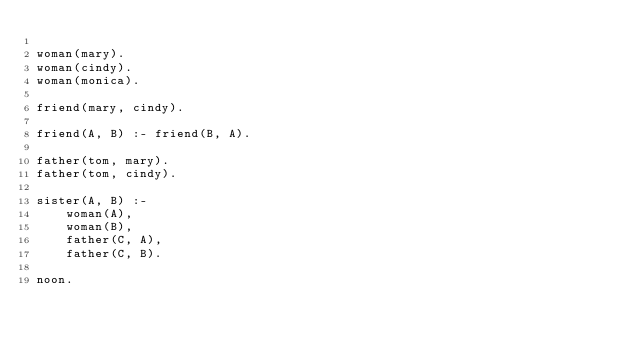<code> <loc_0><loc_0><loc_500><loc_500><_Prolog_>
woman(mary).
woman(cindy).
woman(monica).

friend(mary, cindy).

friend(A, B) :- friend(B, A).

father(tom, mary).
father(tom, cindy).

sister(A, B) :-
	woman(A),
	woman(B),
	father(C, A),
	father(C, B).

noon.
</code> 